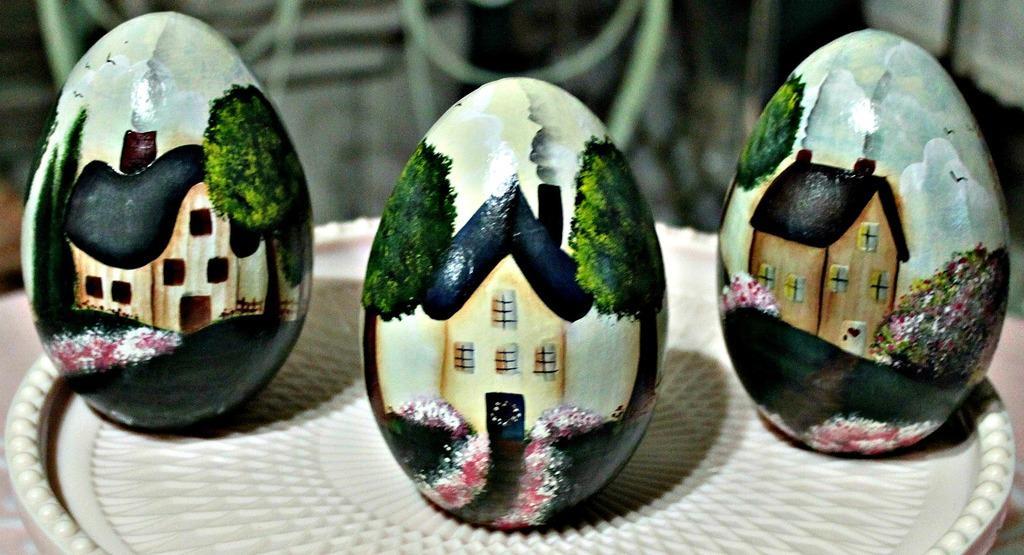Could you give a brief overview of what you see in this image? In this image I can see three eggs, on the eggs I can see a building, trees, flowers painted and these eggs are in the plate and the plate is in white color. 